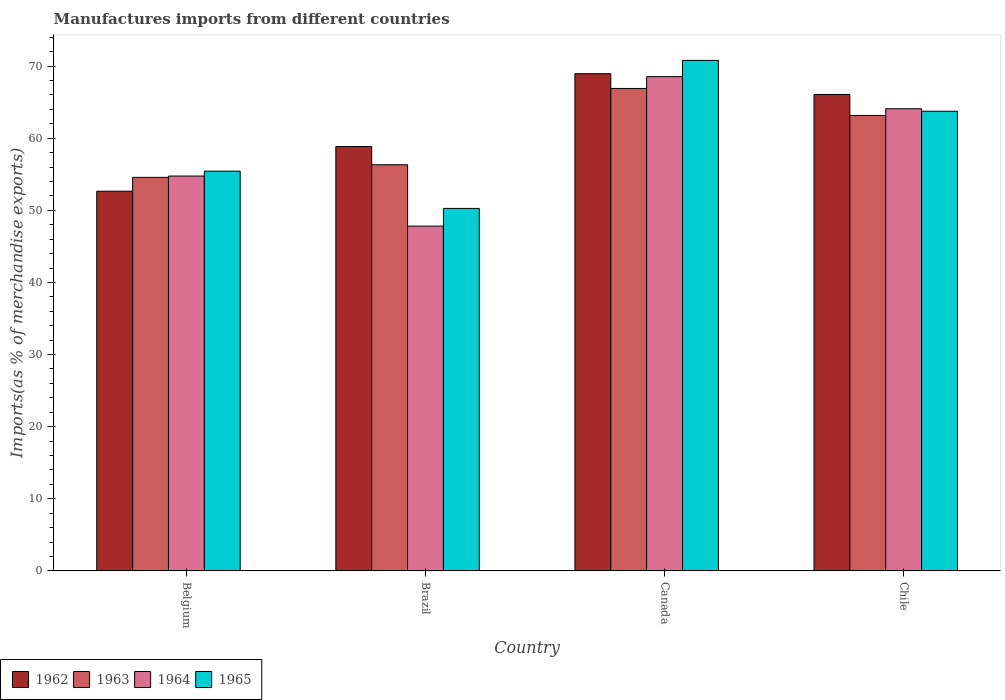How many different coloured bars are there?
Your answer should be compact. 4. How many groups of bars are there?
Provide a short and direct response. 4. How many bars are there on the 3rd tick from the left?
Provide a succinct answer. 4. What is the label of the 2nd group of bars from the left?
Your answer should be compact. Brazil. What is the percentage of imports to different countries in 1964 in Brazil?
Give a very brief answer. 47.82. Across all countries, what is the maximum percentage of imports to different countries in 1963?
Provide a short and direct response. 66.9. Across all countries, what is the minimum percentage of imports to different countries in 1963?
Offer a terse response. 54.57. In which country was the percentage of imports to different countries in 1965 minimum?
Provide a succinct answer. Brazil. What is the total percentage of imports to different countries in 1963 in the graph?
Your answer should be very brief. 240.96. What is the difference between the percentage of imports to different countries in 1964 in Belgium and that in Chile?
Make the answer very short. -9.33. What is the difference between the percentage of imports to different countries in 1964 in Canada and the percentage of imports to different countries in 1963 in Brazil?
Give a very brief answer. 12.21. What is the average percentage of imports to different countries in 1963 per country?
Your answer should be compact. 60.24. What is the difference between the percentage of imports to different countries of/in 1962 and percentage of imports to different countries of/in 1965 in Canada?
Keep it short and to the point. -1.84. What is the ratio of the percentage of imports to different countries in 1965 in Belgium to that in Brazil?
Your answer should be compact. 1.1. Is the difference between the percentage of imports to different countries in 1962 in Belgium and Chile greater than the difference between the percentage of imports to different countries in 1965 in Belgium and Chile?
Offer a very short reply. No. What is the difference between the highest and the second highest percentage of imports to different countries in 1963?
Provide a short and direct response. -10.58. What is the difference between the highest and the lowest percentage of imports to different countries in 1963?
Your response must be concise. 12.33. Is it the case that in every country, the sum of the percentage of imports to different countries in 1964 and percentage of imports to different countries in 1965 is greater than the sum of percentage of imports to different countries in 1963 and percentage of imports to different countries in 1962?
Offer a very short reply. No. What does the 1st bar from the left in Chile represents?
Provide a short and direct response. 1962. What does the 2nd bar from the right in Canada represents?
Your response must be concise. 1964. Is it the case that in every country, the sum of the percentage of imports to different countries in 1962 and percentage of imports to different countries in 1964 is greater than the percentage of imports to different countries in 1963?
Keep it short and to the point. Yes. Are all the bars in the graph horizontal?
Provide a short and direct response. No. How many countries are there in the graph?
Your answer should be very brief. 4. What is the difference between two consecutive major ticks on the Y-axis?
Your answer should be very brief. 10. Are the values on the major ticks of Y-axis written in scientific E-notation?
Your response must be concise. No. Does the graph contain any zero values?
Provide a succinct answer. No. What is the title of the graph?
Keep it short and to the point. Manufactures imports from different countries. What is the label or title of the X-axis?
Keep it short and to the point. Country. What is the label or title of the Y-axis?
Provide a short and direct response. Imports(as % of merchandise exports). What is the Imports(as % of merchandise exports) in 1962 in Belgium?
Make the answer very short. 52.65. What is the Imports(as % of merchandise exports) of 1963 in Belgium?
Ensure brevity in your answer.  54.57. What is the Imports(as % of merchandise exports) of 1964 in Belgium?
Give a very brief answer. 54.75. What is the Imports(as % of merchandise exports) of 1965 in Belgium?
Give a very brief answer. 55.44. What is the Imports(as % of merchandise exports) of 1962 in Brazil?
Give a very brief answer. 58.85. What is the Imports(as % of merchandise exports) in 1963 in Brazil?
Your answer should be compact. 56.32. What is the Imports(as % of merchandise exports) of 1964 in Brazil?
Make the answer very short. 47.82. What is the Imports(as % of merchandise exports) in 1965 in Brazil?
Keep it short and to the point. 50.27. What is the Imports(as % of merchandise exports) of 1962 in Canada?
Offer a terse response. 68.95. What is the Imports(as % of merchandise exports) of 1963 in Canada?
Offer a very short reply. 66.9. What is the Imports(as % of merchandise exports) of 1964 in Canada?
Your response must be concise. 68.54. What is the Imports(as % of merchandise exports) of 1965 in Canada?
Keep it short and to the point. 70.79. What is the Imports(as % of merchandise exports) in 1962 in Chile?
Make the answer very short. 66.07. What is the Imports(as % of merchandise exports) in 1963 in Chile?
Offer a very short reply. 63.16. What is the Imports(as % of merchandise exports) in 1964 in Chile?
Your answer should be very brief. 64.09. What is the Imports(as % of merchandise exports) in 1965 in Chile?
Your answer should be compact. 63.74. Across all countries, what is the maximum Imports(as % of merchandise exports) in 1962?
Your response must be concise. 68.95. Across all countries, what is the maximum Imports(as % of merchandise exports) of 1963?
Ensure brevity in your answer.  66.9. Across all countries, what is the maximum Imports(as % of merchandise exports) of 1964?
Offer a very short reply. 68.54. Across all countries, what is the maximum Imports(as % of merchandise exports) of 1965?
Provide a short and direct response. 70.79. Across all countries, what is the minimum Imports(as % of merchandise exports) in 1962?
Your response must be concise. 52.65. Across all countries, what is the minimum Imports(as % of merchandise exports) in 1963?
Ensure brevity in your answer.  54.57. Across all countries, what is the minimum Imports(as % of merchandise exports) of 1964?
Keep it short and to the point. 47.82. Across all countries, what is the minimum Imports(as % of merchandise exports) in 1965?
Keep it short and to the point. 50.27. What is the total Imports(as % of merchandise exports) in 1962 in the graph?
Offer a very short reply. 246.52. What is the total Imports(as % of merchandise exports) of 1963 in the graph?
Make the answer very short. 240.96. What is the total Imports(as % of merchandise exports) of 1964 in the graph?
Your answer should be very brief. 235.19. What is the total Imports(as % of merchandise exports) in 1965 in the graph?
Ensure brevity in your answer.  240.24. What is the difference between the Imports(as % of merchandise exports) of 1962 in Belgium and that in Brazil?
Offer a terse response. -6.19. What is the difference between the Imports(as % of merchandise exports) in 1963 in Belgium and that in Brazil?
Give a very brief answer. -1.75. What is the difference between the Imports(as % of merchandise exports) in 1964 in Belgium and that in Brazil?
Your answer should be very brief. 6.94. What is the difference between the Imports(as % of merchandise exports) of 1965 in Belgium and that in Brazil?
Offer a terse response. 5.17. What is the difference between the Imports(as % of merchandise exports) of 1962 in Belgium and that in Canada?
Your answer should be compact. -16.3. What is the difference between the Imports(as % of merchandise exports) of 1963 in Belgium and that in Canada?
Provide a succinct answer. -12.33. What is the difference between the Imports(as % of merchandise exports) of 1964 in Belgium and that in Canada?
Offer a very short reply. -13.78. What is the difference between the Imports(as % of merchandise exports) in 1965 in Belgium and that in Canada?
Your response must be concise. -15.36. What is the difference between the Imports(as % of merchandise exports) in 1962 in Belgium and that in Chile?
Make the answer very short. -13.41. What is the difference between the Imports(as % of merchandise exports) in 1963 in Belgium and that in Chile?
Offer a terse response. -8.59. What is the difference between the Imports(as % of merchandise exports) in 1964 in Belgium and that in Chile?
Your answer should be very brief. -9.33. What is the difference between the Imports(as % of merchandise exports) in 1965 in Belgium and that in Chile?
Keep it short and to the point. -8.31. What is the difference between the Imports(as % of merchandise exports) in 1962 in Brazil and that in Canada?
Give a very brief answer. -10.1. What is the difference between the Imports(as % of merchandise exports) of 1963 in Brazil and that in Canada?
Provide a short and direct response. -10.58. What is the difference between the Imports(as % of merchandise exports) in 1964 in Brazil and that in Canada?
Your answer should be very brief. -20.72. What is the difference between the Imports(as % of merchandise exports) in 1965 in Brazil and that in Canada?
Give a very brief answer. -20.53. What is the difference between the Imports(as % of merchandise exports) in 1962 in Brazil and that in Chile?
Your answer should be very brief. -7.22. What is the difference between the Imports(as % of merchandise exports) in 1963 in Brazil and that in Chile?
Offer a very short reply. -6.84. What is the difference between the Imports(as % of merchandise exports) in 1964 in Brazil and that in Chile?
Keep it short and to the point. -16.27. What is the difference between the Imports(as % of merchandise exports) in 1965 in Brazil and that in Chile?
Keep it short and to the point. -13.48. What is the difference between the Imports(as % of merchandise exports) of 1962 in Canada and that in Chile?
Your answer should be very brief. 2.88. What is the difference between the Imports(as % of merchandise exports) of 1963 in Canada and that in Chile?
Your answer should be compact. 3.74. What is the difference between the Imports(as % of merchandise exports) of 1964 in Canada and that in Chile?
Your response must be concise. 4.45. What is the difference between the Imports(as % of merchandise exports) of 1965 in Canada and that in Chile?
Offer a terse response. 7.05. What is the difference between the Imports(as % of merchandise exports) of 1962 in Belgium and the Imports(as % of merchandise exports) of 1963 in Brazil?
Give a very brief answer. -3.67. What is the difference between the Imports(as % of merchandise exports) of 1962 in Belgium and the Imports(as % of merchandise exports) of 1964 in Brazil?
Provide a succinct answer. 4.84. What is the difference between the Imports(as % of merchandise exports) of 1962 in Belgium and the Imports(as % of merchandise exports) of 1965 in Brazil?
Make the answer very short. 2.39. What is the difference between the Imports(as % of merchandise exports) of 1963 in Belgium and the Imports(as % of merchandise exports) of 1964 in Brazil?
Make the answer very short. 6.76. What is the difference between the Imports(as % of merchandise exports) of 1963 in Belgium and the Imports(as % of merchandise exports) of 1965 in Brazil?
Your answer should be very brief. 4.31. What is the difference between the Imports(as % of merchandise exports) of 1964 in Belgium and the Imports(as % of merchandise exports) of 1965 in Brazil?
Your answer should be very brief. 4.49. What is the difference between the Imports(as % of merchandise exports) of 1962 in Belgium and the Imports(as % of merchandise exports) of 1963 in Canada?
Make the answer very short. -14.25. What is the difference between the Imports(as % of merchandise exports) of 1962 in Belgium and the Imports(as % of merchandise exports) of 1964 in Canada?
Your answer should be very brief. -15.88. What is the difference between the Imports(as % of merchandise exports) in 1962 in Belgium and the Imports(as % of merchandise exports) in 1965 in Canada?
Give a very brief answer. -18.14. What is the difference between the Imports(as % of merchandise exports) in 1963 in Belgium and the Imports(as % of merchandise exports) in 1964 in Canada?
Offer a terse response. -13.96. What is the difference between the Imports(as % of merchandise exports) in 1963 in Belgium and the Imports(as % of merchandise exports) in 1965 in Canada?
Ensure brevity in your answer.  -16.22. What is the difference between the Imports(as % of merchandise exports) in 1964 in Belgium and the Imports(as % of merchandise exports) in 1965 in Canada?
Provide a short and direct response. -16.04. What is the difference between the Imports(as % of merchandise exports) of 1962 in Belgium and the Imports(as % of merchandise exports) of 1963 in Chile?
Offer a very short reply. -10.51. What is the difference between the Imports(as % of merchandise exports) in 1962 in Belgium and the Imports(as % of merchandise exports) in 1964 in Chile?
Your answer should be compact. -11.43. What is the difference between the Imports(as % of merchandise exports) in 1962 in Belgium and the Imports(as % of merchandise exports) in 1965 in Chile?
Offer a very short reply. -11.09. What is the difference between the Imports(as % of merchandise exports) of 1963 in Belgium and the Imports(as % of merchandise exports) of 1964 in Chile?
Give a very brief answer. -9.51. What is the difference between the Imports(as % of merchandise exports) of 1963 in Belgium and the Imports(as % of merchandise exports) of 1965 in Chile?
Provide a short and direct response. -9.17. What is the difference between the Imports(as % of merchandise exports) of 1964 in Belgium and the Imports(as % of merchandise exports) of 1965 in Chile?
Ensure brevity in your answer.  -8.99. What is the difference between the Imports(as % of merchandise exports) of 1962 in Brazil and the Imports(as % of merchandise exports) of 1963 in Canada?
Your answer should be compact. -8.06. What is the difference between the Imports(as % of merchandise exports) of 1962 in Brazil and the Imports(as % of merchandise exports) of 1964 in Canada?
Your answer should be compact. -9.69. What is the difference between the Imports(as % of merchandise exports) of 1962 in Brazil and the Imports(as % of merchandise exports) of 1965 in Canada?
Keep it short and to the point. -11.95. What is the difference between the Imports(as % of merchandise exports) in 1963 in Brazil and the Imports(as % of merchandise exports) in 1964 in Canada?
Provide a succinct answer. -12.21. What is the difference between the Imports(as % of merchandise exports) of 1963 in Brazil and the Imports(as % of merchandise exports) of 1965 in Canada?
Offer a very short reply. -14.47. What is the difference between the Imports(as % of merchandise exports) of 1964 in Brazil and the Imports(as % of merchandise exports) of 1965 in Canada?
Give a very brief answer. -22.98. What is the difference between the Imports(as % of merchandise exports) of 1962 in Brazil and the Imports(as % of merchandise exports) of 1963 in Chile?
Give a very brief answer. -4.31. What is the difference between the Imports(as % of merchandise exports) in 1962 in Brazil and the Imports(as % of merchandise exports) in 1964 in Chile?
Give a very brief answer. -5.24. What is the difference between the Imports(as % of merchandise exports) in 1962 in Brazil and the Imports(as % of merchandise exports) in 1965 in Chile?
Give a very brief answer. -4.9. What is the difference between the Imports(as % of merchandise exports) of 1963 in Brazil and the Imports(as % of merchandise exports) of 1964 in Chile?
Offer a very short reply. -7.76. What is the difference between the Imports(as % of merchandise exports) in 1963 in Brazil and the Imports(as % of merchandise exports) in 1965 in Chile?
Your response must be concise. -7.42. What is the difference between the Imports(as % of merchandise exports) of 1964 in Brazil and the Imports(as % of merchandise exports) of 1965 in Chile?
Offer a terse response. -15.93. What is the difference between the Imports(as % of merchandise exports) in 1962 in Canada and the Imports(as % of merchandise exports) in 1963 in Chile?
Offer a very short reply. 5.79. What is the difference between the Imports(as % of merchandise exports) in 1962 in Canada and the Imports(as % of merchandise exports) in 1964 in Chile?
Your answer should be compact. 4.86. What is the difference between the Imports(as % of merchandise exports) of 1962 in Canada and the Imports(as % of merchandise exports) of 1965 in Chile?
Ensure brevity in your answer.  5.21. What is the difference between the Imports(as % of merchandise exports) of 1963 in Canada and the Imports(as % of merchandise exports) of 1964 in Chile?
Your answer should be very brief. 2.82. What is the difference between the Imports(as % of merchandise exports) of 1963 in Canada and the Imports(as % of merchandise exports) of 1965 in Chile?
Offer a terse response. 3.16. What is the difference between the Imports(as % of merchandise exports) in 1964 in Canada and the Imports(as % of merchandise exports) in 1965 in Chile?
Give a very brief answer. 4.79. What is the average Imports(as % of merchandise exports) in 1962 per country?
Ensure brevity in your answer.  61.63. What is the average Imports(as % of merchandise exports) in 1963 per country?
Keep it short and to the point. 60.24. What is the average Imports(as % of merchandise exports) in 1964 per country?
Provide a succinct answer. 58.8. What is the average Imports(as % of merchandise exports) of 1965 per country?
Your answer should be compact. 60.06. What is the difference between the Imports(as % of merchandise exports) of 1962 and Imports(as % of merchandise exports) of 1963 in Belgium?
Ensure brevity in your answer.  -1.92. What is the difference between the Imports(as % of merchandise exports) of 1962 and Imports(as % of merchandise exports) of 1964 in Belgium?
Make the answer very short. -2.1. What is the difference between the Imports(as % of merchandise exports) in 1962 and Imports(as % of merchandise exports) in 1965 in Belgium?
Make the answer very short. -2.78. What is the difference between the Imports(as % of merchandise exports) of 1963 and Imports(as % of merchandise exports) of 1964 in Belgium?
Your response must be concise. -0.18. What is the difference between the Imports(as % of merchandise exports) of 1963 and Imports(as % of merchandise exports) of 1965 in Belgium?
Provide a succinct answer. -0.86. What is the difference between the Imports(as % of merchandise exports) of 1964 and Imports(as % of merchandise exports) of 1965 in Belgium?
Provide a succinct answer. -0.68. What is the difference between the Imports(as % of merchandise exports) of 1962 and Imports(as % of merchandise exports) of 1963 in Brazil?
Your answer should be very brief. 2.52. What is the difference between the Imports(as % of merchandise exports) of 1962 and Imports(as % of merchandise exports) of 1964 in Brazil?
Give a very brief answer. 11.03. What is the difference between the Imports(as % of merchandise exports) of 1962 and Imports(as % of merchandise exports) of 1965 in Brazil?
Your response must be concise. 8.58. What is the difference between the Imports(as % of merchandise exports) of 1963 and Imports(as % of merchandise exports) of 1964 in Brazil?
Give a very brief answer. 8.51. What is the difference between the Imports(as % of merchandise exports) of 1963 and Imports(as % of merchandise exports) of 1965 in Brazil?
Provide a succinct answer. 6.06. What is the difference between the Imports(as % of merchandise exports) of 1964 and Imports(as % of merchandise exports) of 1965 in Brazil?
Keep it short and to the point. -2.45. What is the difference between the Imports(as % of merchandise exports) of 1962 and Imports(as % of merchandise exports) of 1963 in Canada?
Your answer should be compact. 2.05. What is the difference between the Imports(as % of merchandise exports) of 1962 and Imports(as % of merchandise exports) of 1964 in Canada?
Make the answer very short. 0.41. What is the difference between the Imports(as % of merchandise exports) in 1962 and Imports(as % of merchandise exports) in 1965 in Canada?
Provide a succinct answer. -1.84. What is the difference between the Imports(as % of merchandise exports) of 1963 and Imports(as % of merchandise exports) of 1964 in Canada?
Give a very brief answer. -1.64. What is the difference between the Imports(as % of merchandise exports) of 1963 and Imports(as % of merchandise exports) of 1965 in Canada?
Ensure brevity in your answer.  -3.89. What is the difference between the Imports(as % of merchandise exports) of 1964 and Imports(as % of merchandise exports) of 1965 in Canada?
Provide a short and direct response. -2.26. What is the difference between the Imports(as % of merchandise exports) of 1962 and Imports(as % of merchandise exports) of 1963 in Chile?
Provide a succinct answer. 2.91. What is the difference between the Imports(as % of merchandise exports) in 1962 and Imports(as % of merchandise exports) in 1964 in Chile?
Keep it short and to the point. 1.98. What is the difference between the Imports(as % of merchandise exports) of 1962 and Imports(as % of merchandise exports) of 1965 in Chile?
Your answer should be compact. 2.32. What is the difference between the Imports(as % of merchandise exports) of 1963 and Imports(as % of merchandise exports) of 1964 in Chile?
Make the answer very short. -0.93. What is the difference between the Imports(as % of merchandise exports) in 1963 and Imports(as % of merchandise exports) in 1965 in Chile?
Keep it short and to the point. -0.59. What is the difference between the Imports(as % of merchandise exports) of 1964 and Imports(as % of merchandise exports) of 1965 in Chile?
Your response must be concise. 0.34. What is the ratio of the Imports(as % of merchandise exports) of 1962 in Belgium to that in Brazil?
Provide a succinct answer. 0.89. What is the ratio of the Imports(as % of merchandise exports) of 1963 in Belgium to that in Brazil?
Your answer should be compact. 0.97. What is the ratio of the Imports(as % of merchandise exports) of 1964 in Belgium to that in Brazil?
Offer a terse response. 1.15. What is the ratio of the Imports(as % of merchandise exports) in 1965 in Belgium to that in Brazil?
Provide a succinct answer. 1.1. What is the ratio of the Imports(as % of merchandise exports) of 1962 in Belgium to that in Canada?
Provide a succinct answer. 0.76. What is the ratio of the Imports(as % of merchandise exports) of 1963 in Belgium to that in Canada?
Provide a succinct answer. 0.82. What is the ratio of the Imports(as % of merchandise exports) in 1964 in Belgium to that in Canada?
Keep it short and to the point. 0.8. What is the ratio of the Imports(as % of merchandise exports) of 1965 in Belgium to that in Canada?
Your answer should be very brief. 0.78. What is the ratio of the Imports(as % of merchandise exports) in 1962 in Belgium to that in Chile?
Offer a very short reply. 0.8. What is the ratio of the Imports(as % of merchandise exports) in 1963 in Belgium to that in Chile?
Offer a terse response. 0.86. What is the ratio of the Imports(as % of merchandise exports) of 1964 in Belgium to that in Chile?
Make the answer very short. 0.85. What is the ratio of the Imports(as % of merchandise exports) in 1965 in Belgium to that in Chile?
Provide a succinct answer. 0.87. What is the ratio of the Imports(as % of merchandise exports) in 1962 in Brazil to that in Canada?
Make the answer very short. 0.85. What is the ratio of the Imports(as % of merchandise exports) of 1963 in Brazil to that in Canada?
Your response must be concise. 0.84. What is the ratio of the Imports(as % of merchandise exports) in 1964 in Brazil to that in Canada?
Your answer should be very brief. 0.7. What is the ratio of the Imports(as % of merchandise exports) in 1965 in Brazil to that in Canada?
Provide a succinct answer. 0.71. What is the ratio of the Imports(as % of merchandise exports) in 1962 in Brazil to that in Chile?
Offer a very short reply. 0.89. What is the ratio of the Imports(as % of merchandise exports) in 1963 in Brazil to that in Chile?
Offer a terse response. 0.89. What is the ratio of the Imports(as % of merchandise exports) of 1964 in Brazil to that in Chile?
Make the answer very short. 0.75. What is the ratio of the Imports(as % of merchandise exports) in 1965 in Brazil to that in Chile?
Offer a very short reply. 0.79. What is the ratio of the Imports(as % of merchandise exports) of 1962 in Canada to that in Chile?
Provide a succinct answer. 1.04. What is the ratio of the Imports(as % of merchandise exports) of 1963 in Canada to that in Chile?
Keep it short and to the point. 1.06. What is the ratio of the Imports(as % of merchandise exports) in 1964 in Canada to that in Chile?
Keep it short and to the point. 1.07. What is the ratio of the Imports(as % of merchandise exports) in 1965 in Canada to that in Chile?
Make the answer very short. 1.11. What is the difference between the highest and the second highest Imports(as % of merchandise exports) of 1962?
Make the answer very short. 2.88. What is the difference between the highest and the second highest Imports(as % of merchandise exports) in 1963?
Provide a succinct answer. 3.74. What is the difference between the highest and the second highest Imports(as % of merchandise exports) in 1964?
Give a very brief answer. 4.45. What is the difference between the highest and the second highest Imports(as % of merchandise exports) in 1965?
Make the answer very short. 7.05. What is the difference between the highest and the lowest Imports(as % of merchandise exports) in 1962?
Provide a succinct answer. 16.3. What is the difference between the highest and the lowest Imports(as % of merchandise exports) in 1963?
Provide a short and direct response. 12.33. What is the difference between the highest and the lowest Imports(as % of merchandise exports) in 1964?
Your answer should be very brief. 20.72. What is the difference between the highest and the lowest Imports(as % of merchandise exports) of 1965?
Your response must be concise. 20.53. 